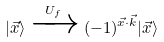Convert formula to latex. <formula><loc_0><loc_0><loc_500><loc_500>| \vec { x } \rangle \xrightarrow { U _ { f } } ( - 1 ) ^ { \vec { x } \cdot \vec { k } } | \vec { x } \rangle</formula> 